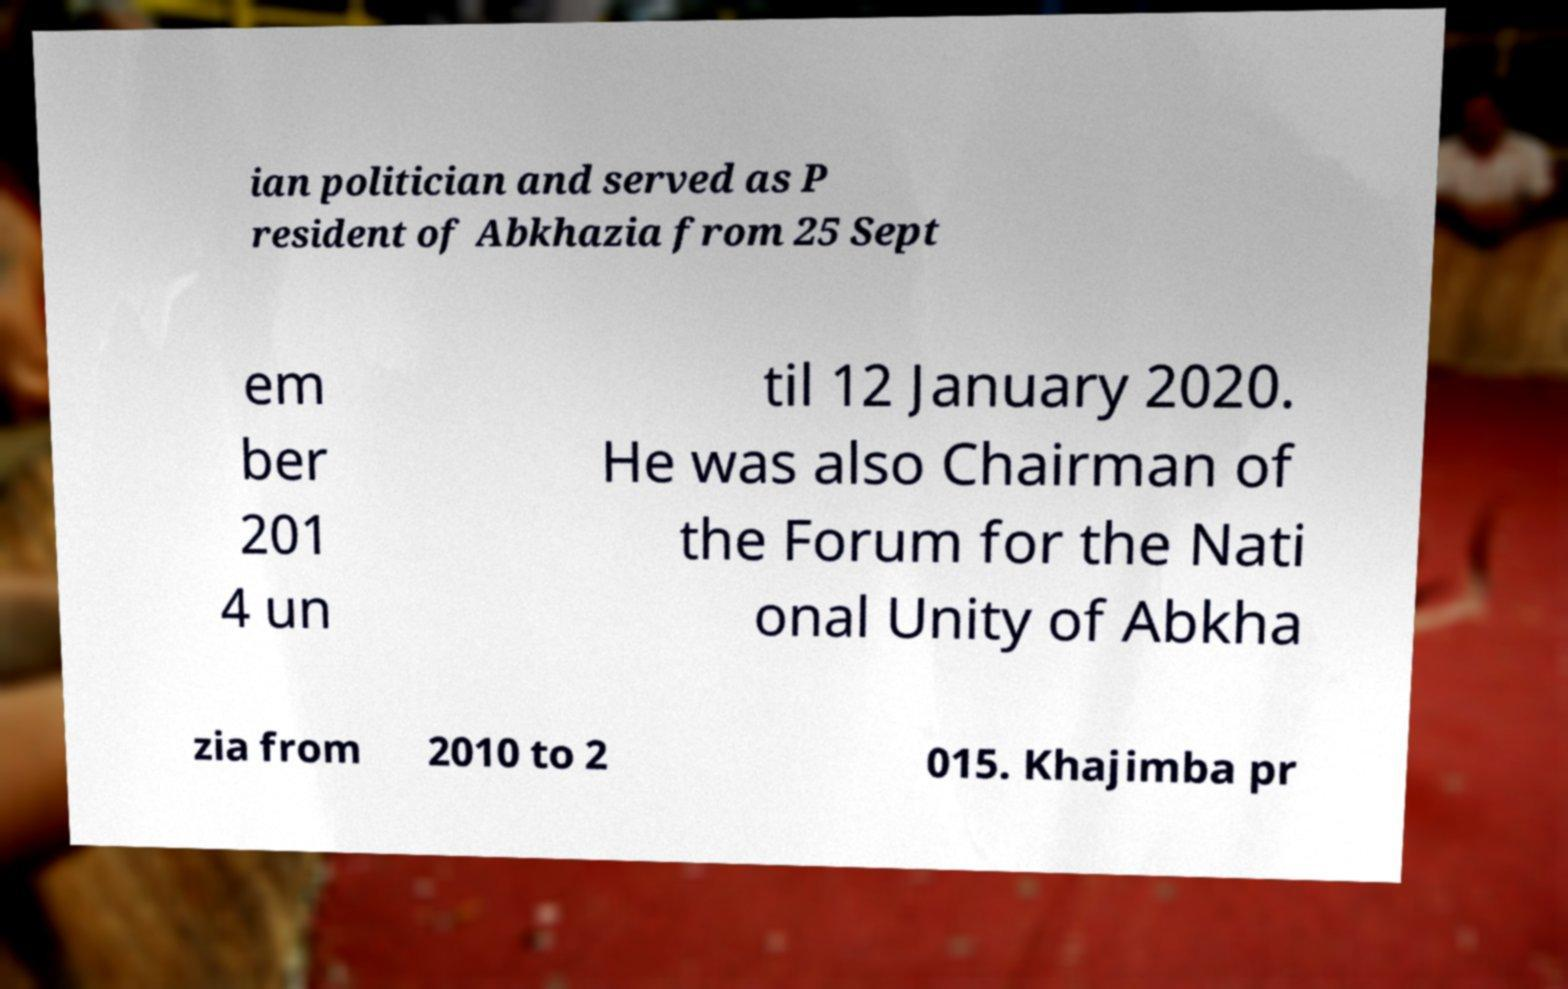Could you extract and type out the text from this image? ian politician and served as P resident of Abkhazia from 25 Sept em ber 201 4 un til 12 January 2020. He was also Chairman of the Forum for the Nati onal Unity of Abkha zia from 2010 to 2 015. Khajimba pr 